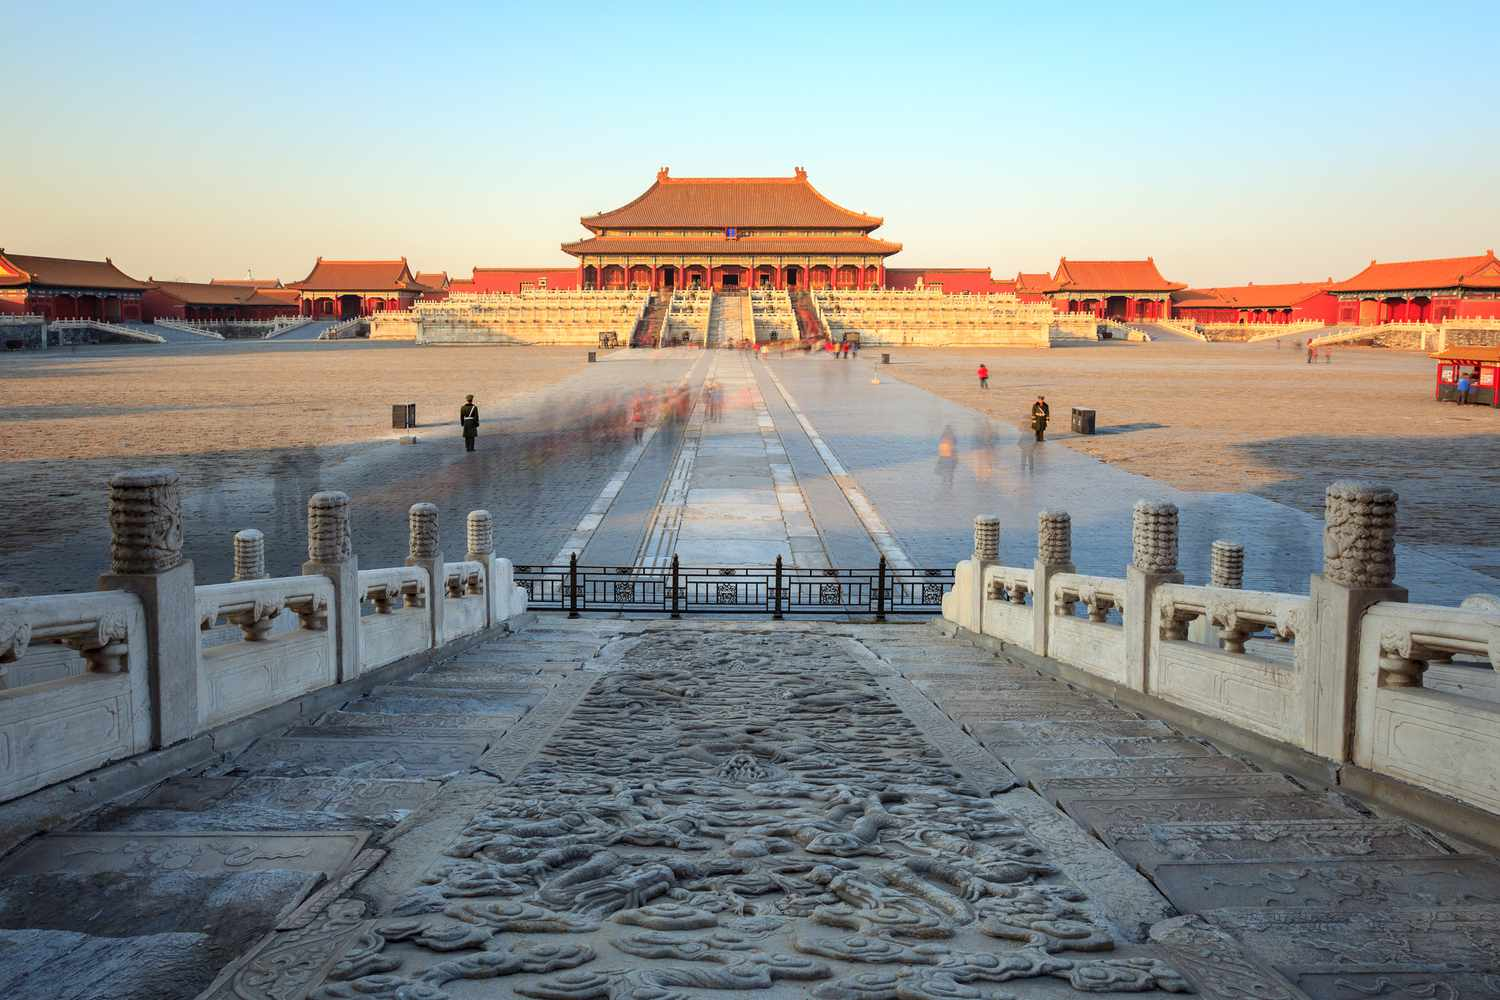Imagine a dramatic event unfolding here. In the heart of the Forbidden City, on a day when the emperor declared a crucial edict, the grand courtyard overflowed with anticipation. The golden roofs shimmered brilliantly against the azure sky. Suddenly, a rider appearing from the north gate breaks the solemn air, bringing urgent news of an impending invasion. The atmosphere thickened with tension as ministers hurried to the Hall of Supreme Harmony, their ornate robes billowing in the wind. Inside, the emperor, a beacon of calm amidst the swirling chaos, summoned his most trusted strategists. Candles flared angrily against the growing gloom of evening twilight, their flickering light casting long, danced shadows on the walls. The silent stone lions seemed to growl as the weight of impending history pressed down upon the city. 